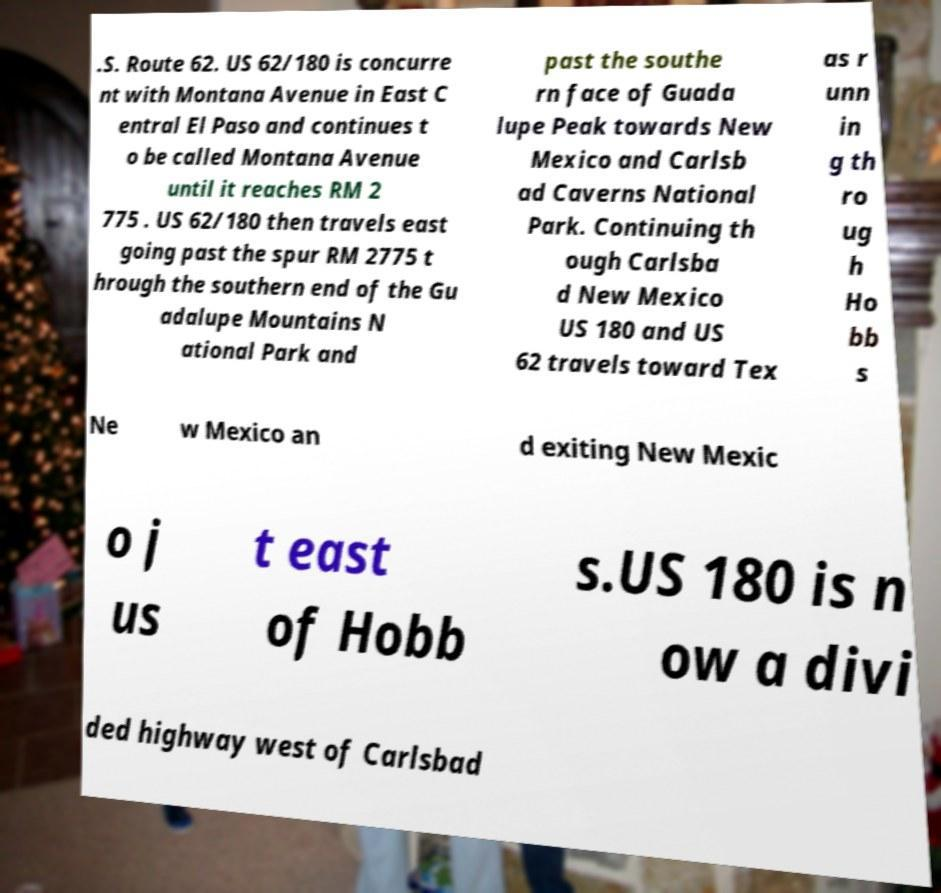For documentation purposes, I need the text within this image transcribed. Could you provide that? .S. Route 62. US 62/180 is concurre nt with Montana Avenue in East C entral El Paso and continues t o be called Montana Avenue until it reaches RM 2 775 . US 62/180 then travels east going past the spur RM 2775 t hrough the southern end of the Gu adalupe Mountains N ational Park and past the southe rn face of Guada lupe Peak towards New Mexico and Carlsb ad Caverns National Park. Continuing th ough Carlsba d New Mexico US 180 and US 62 travels toward Tex as r unn in g th ro ug h Ho bb s Ne w Mexico an d exiting New Mexic o j us t east of Hobb s.US 180 is n ow a divi ded highway west of Carlsbad 